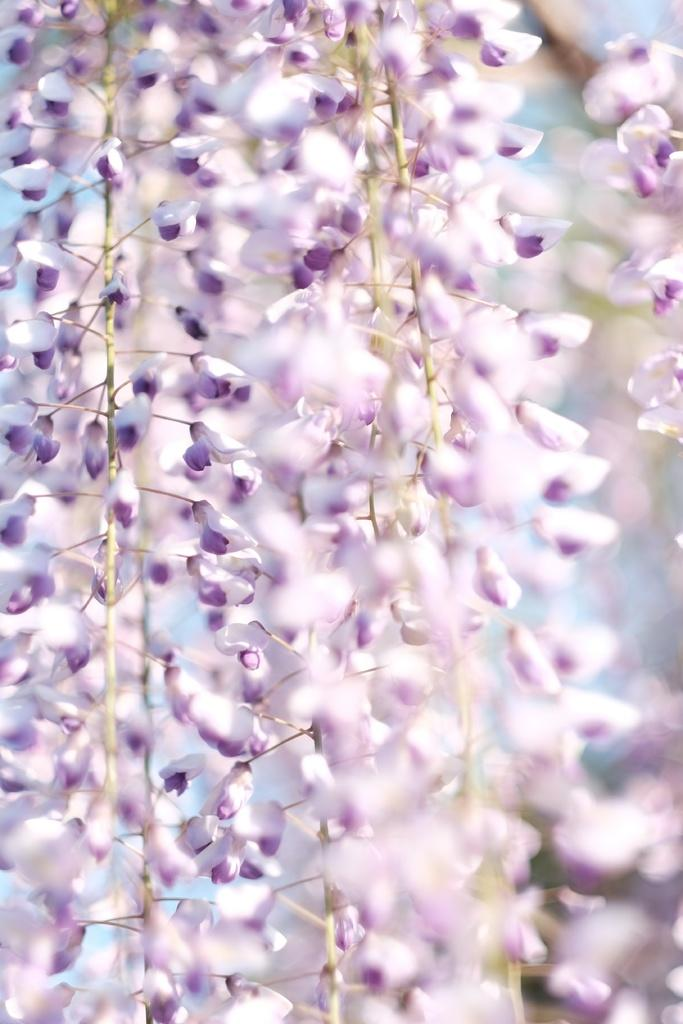What type of plant is depicted in the image? There are stems with flowers in the image. Can you describe the background of the image? The background appears blurry in the image. What type of birds can be heard singing in the image? There are no birds present in the image, and therefore no sounds can be heard. 